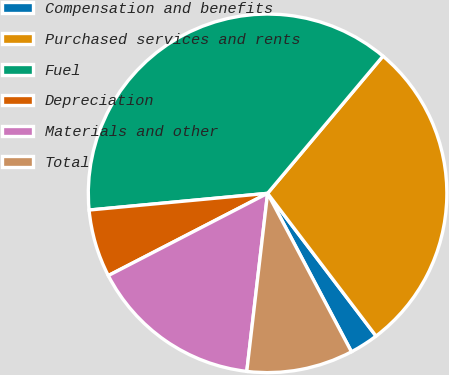<chart> <loc_0><loc_0><loc_500><loc_500><pie_chart><fcel>Compensation and benefits<fcel>Purchased services and rents<fcel>Fuel<fcel>Depreciation<fcel>Materials and other<fcel>Total<nl><fcel>2.59%<fcel>28.53%<fcel>37.61%<fcel>6.1%<fcel>15.56%<fcel>9.6%<nl></chart> 